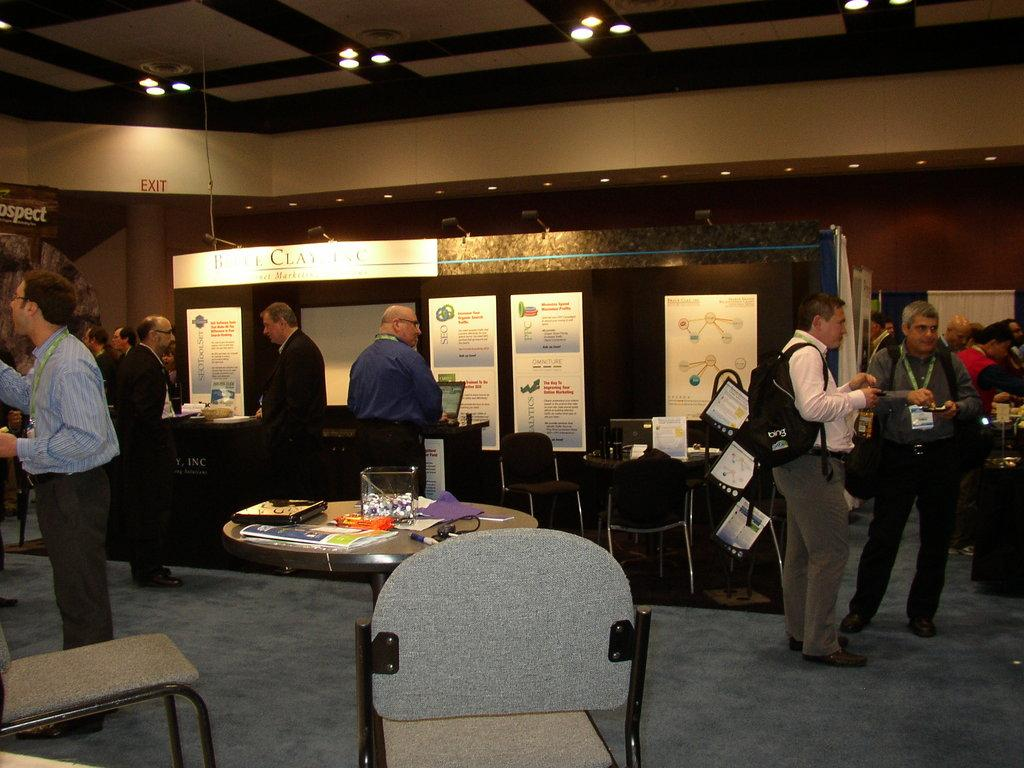How many people are in the image? There is a group of people standing in the image. What type of furniture is present in the image? There are chairs and a table in the image. What is on the table? Papers and a box are present on the table. What can be seen in the background of the image? There is a name board, a board, papers, and lights visible in the background of the image. How many icicles can be seen hanging from the board in the background of the image? There are no icicles present in the image; it is indoors and there is no mention of cold weather or ice. 